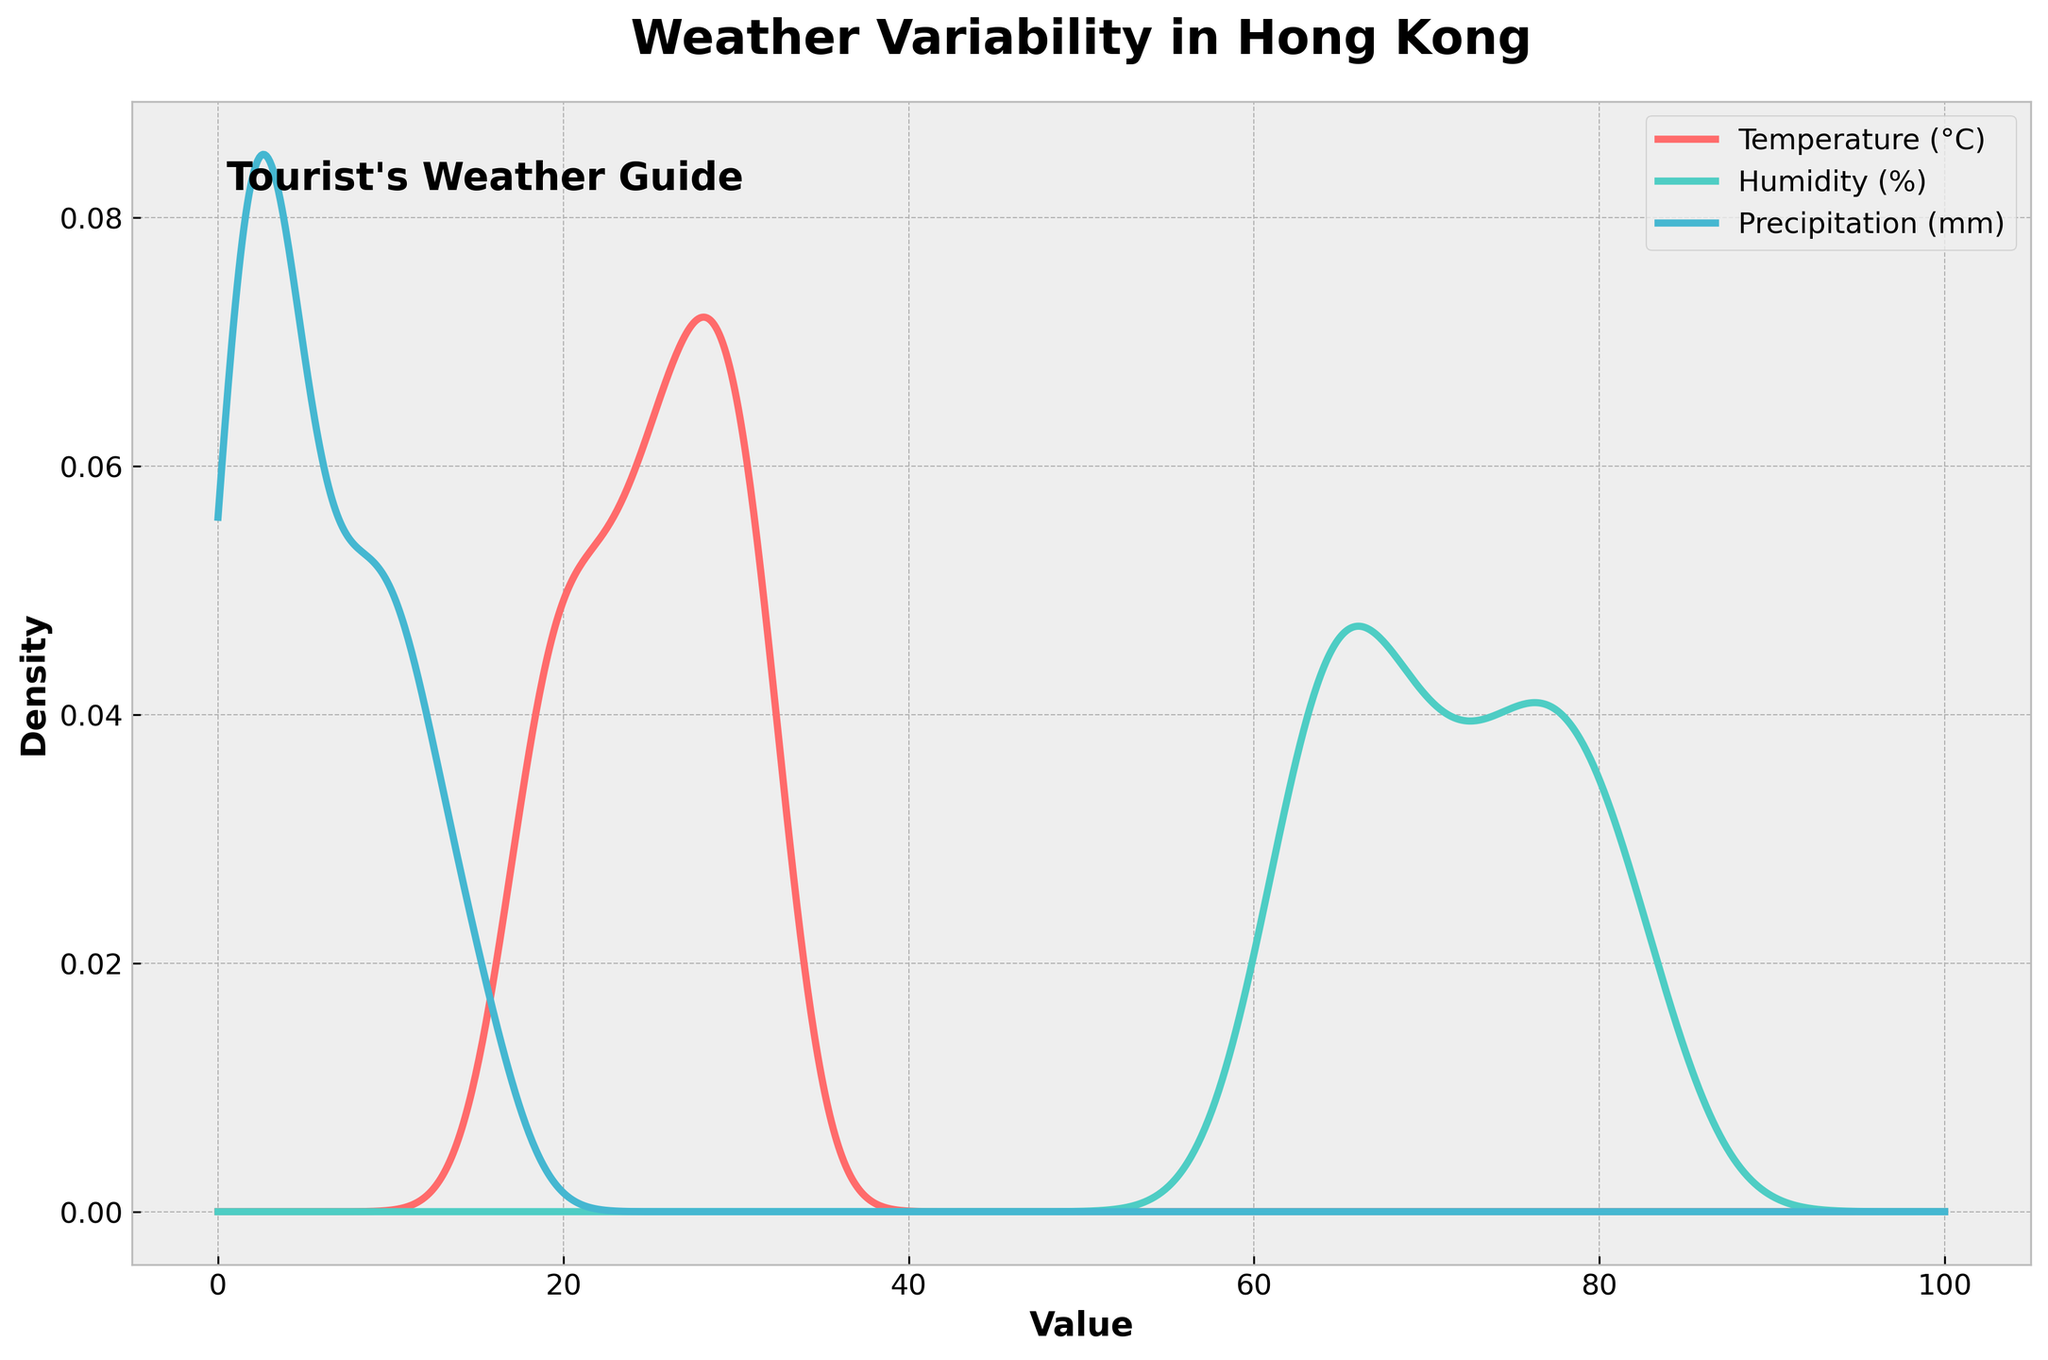What are the three variables displayed in the density plot? The figure shows three different density plots, each representing a specific weather variable. The labels on the plot indicate that the three variables are "Temperature (°C)," "Humidity (%)," and "Precipitation (mm)."
Answer: Temperature (°C), Humidity (%), Precipitation (mm) What color represents the temperature density plot? In the figure, the temperature density plot is represented by the color line, which is labeled in the legend with that specific color. The color for the temperature density plot is a shade of red.
Answer: Red Which variable has the highest peak density value? By observing the density curves' peaks on the plot, you can determine which variable's density curve reaches the highest point. The curve with the highest peak represents the variable with the highest density value at a certain point.
Answer: Temperature Is the precipitation density curve broader compared to the other two variables? To determine the width of the density curves, you can observe how spread out each curve is across the x-axis. A broader curve will span a larger range of x-axis values.
Answer: Yes Between humidity and precipitation, which one has more variability? Variability can be inferred from the density plot by looking at the spread of the density curves. A wider spread indicates more variability. By comparing the widths of the humidity and precipitation density curves, you can determine which one is broader.
Answer: Precipitation What is the approximate value where the humidity density curve peaks? To find the approximate value where the humidity density curve peaks, look at the highest point of the cyan density curve and trace it down to the x-axis. The x-axis value at this point represents the peak.
Answer: Around 65-75% If a tourist prefers moderate temperatures, around which month should they visit Hong Kong? Moderate temperatures refer to a range that is not too hot or too cold. By looking at where the temperature density curve has substantial density (between low and high temperature extremes), you can infer which range of months would fall into this category by tracing these values back to the given dataset.
Answer: November to March Compare the peak heights of the humidity and precipitation density curves. Which is taller? By visually assessing the tallest points of the cyan (humidity) and blue (precipitation) density curves, you determine which peak rises higher above the x-axis.
Answer: Humidity What does the x-axis represent in this plot? The x-axis usually represents the values of the data being measured. In this density plot, the x-axis ranges from 0 to 100 and serves as the common value axis for the three variables being plotted: temperature, humidity, and precipitation.
Answer: Value How do the peak density values of temperature and precipitation compare? To compare the peaks, you look at the highest points on the red (temperature) and blue (precipitation) curves. Comparing the heights of these peaks reveals which variable has a higher peak density.
Answer: Temperature is higher 